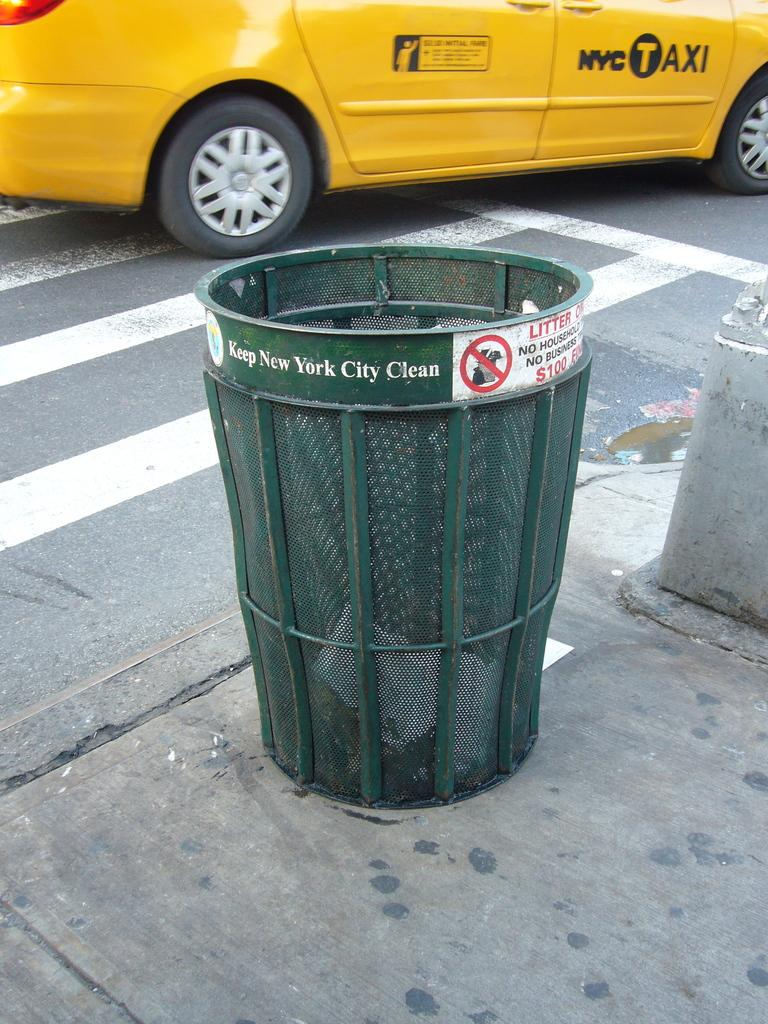<image>
Present a compact description of the photo's key features. The green trash can shown here is in New York City 